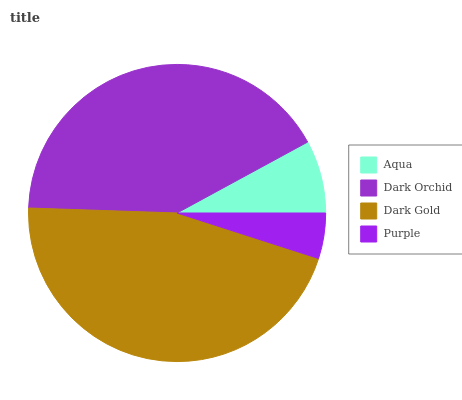Is Purple the minimum?
Answer yes or no. Yes. Is Dark Gold the maximum?
Answer yes or no. Yes. Is Dark Orchid the minimum?
Answer yes or no. No. Is Dark Orchid the maximum?
Answer yes or no. No. Is Dark Orchid greater than Aqua?
Answer yes or no. Yes. Is Aqua less than Dark Orchid?
Answer yes or no. Yes. Is Aqua greater than Dark Orchid?
Answer yes or no. No. Is Dark Orchid less than Aqua?
Answer yes or no. No. Is Dark Orchid the high median?
Answer yes or no. Yes. Is Aqua the low median?
Answer yes or no. Yes. Is Purple the high median?
Answer yes or no. No. Is Purple the low median?
Answer yes or no. No. 